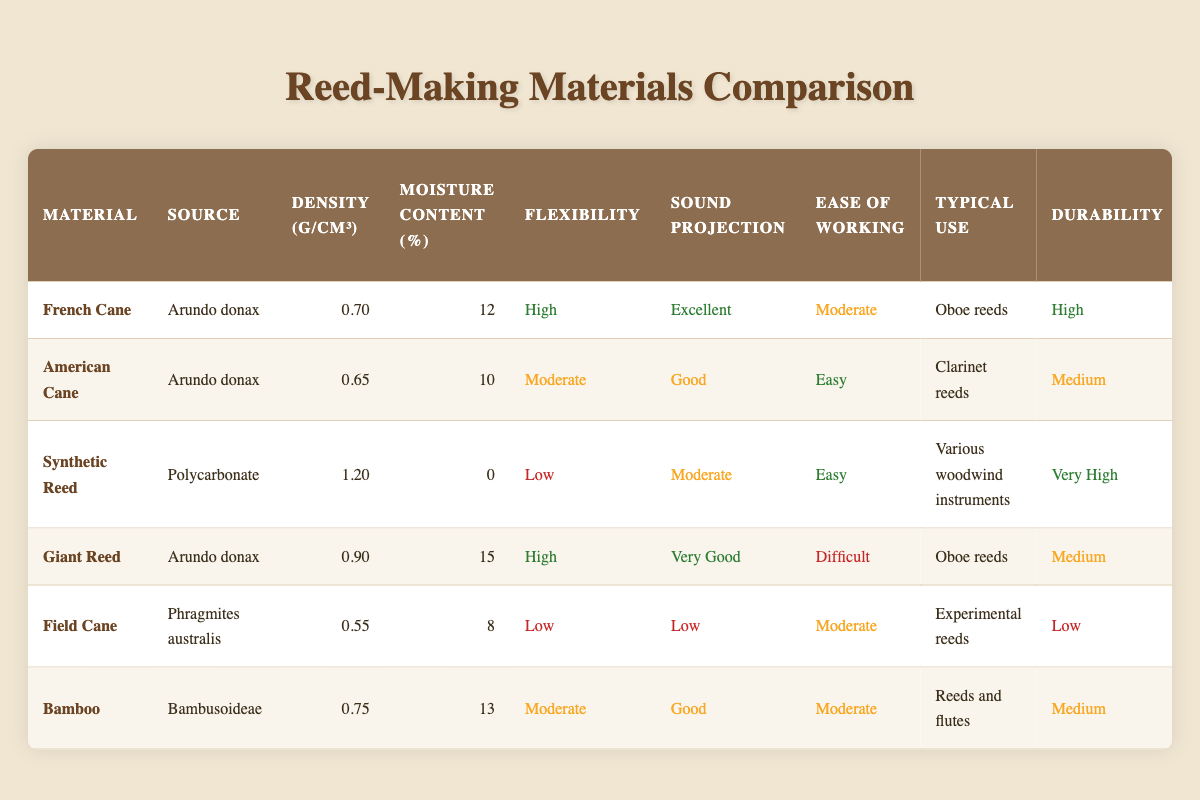What is the moisture content percentage of French Cane? In the table, locate the row for French Cane and read the value under the Moisture Content (%) column, which is 12.
Answer: 12 Which material has the highest durability rating? Review the Durability column for all materials and find that Synthetic Reed has the highest rating of "Very High".
Answer: Synthetic Reed What is the average cost per bundle of all materials? To find the average cost, sum the costs: (30 + 25 + 40 + 35 + 15 + 20) = 165. Since there are 6 materials, divide by 6: 165/6 = 27.5.
Answer: 27.5 Is Giant Reed more expensive than American Cane? Compare the Cost per Bundle (USD) for both materials: Giant Reed is $35 and American Cane is $25. Since 35 > 25, the statement is true.
Answer: Yes Which material has the best sound projection? Look under the Sound Projection column and see that French Cane has "Excellent", which is the highest rating.
Answer: French Cane If you want a material that is easy to work with, which two options could you choose? Review the Ease of Working column and see that both American Cane and Synthetic Reed are rated as "Easy".
Answer: American Cane, Synthetic Reed Can you find a material with low flexibility and low sound projection? Examine both the Flexibility and Sound Projection columns for materials that meet these criteria: Field Cane is rated "Low" for both.
Answer: Field Cane What is the difference in cost between Synthetic Reed and Bamboo? Identify the costs: Synthetic Reed ($40) and Bamboo ($20). The difference is 40 - 20 = 20.
Answer: 20 What is the flexibility rating of Bamboo? Locate Bamboo in the table and check the Flexibility column where it's rated "Moderate".
Answer: Moderate Which material is known for high sound projection specifically used for oboe reeds? Look under Typical Use and find that both French Cane and Giant Reed are used for oboe reeds. Now, compare their sound projections: French Cane has "Excellent" and Giant Reed has "Very Good". Thus, French Cane has the highest sound projection.
Answer: French Cane Are there any materials with a density less than 0.6 g/cm³? Check the Density column for all materials: Field Cane has a density of 0.55, which is the only one under 0.6 g/cm³.
Answer: Yes, Field Cane 